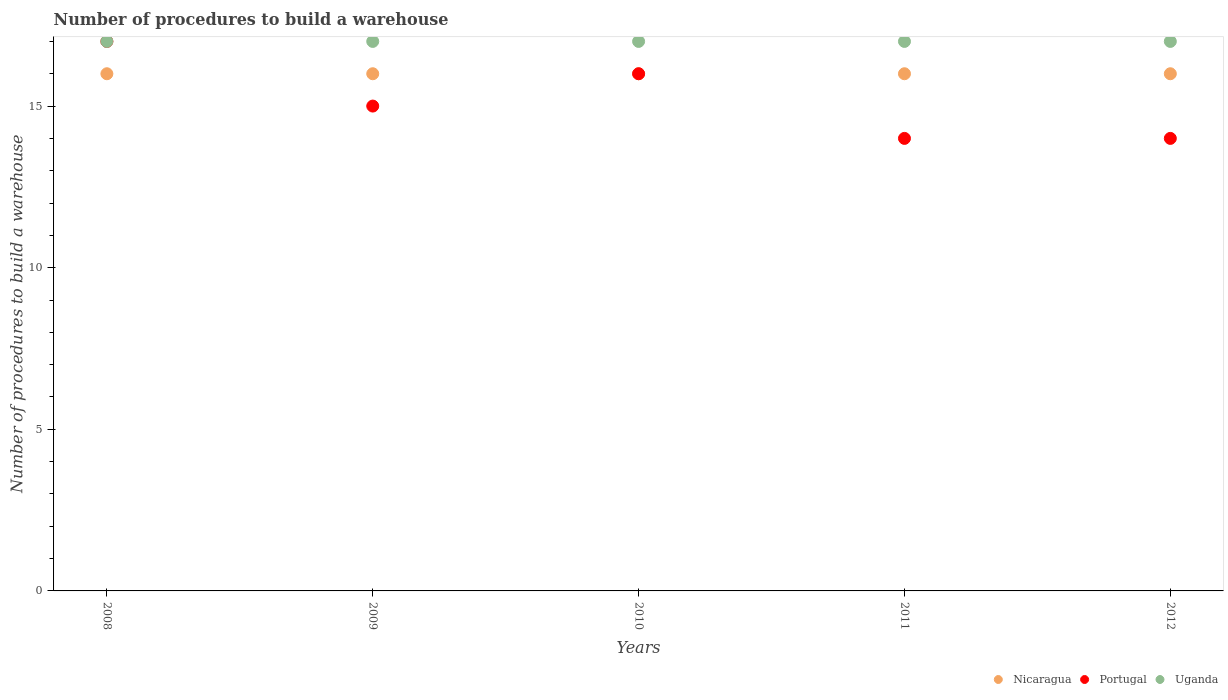How many different coloured dotlines are there?
Your answer should be compact. 3. What is the number of procedures to build a warehouse in in Portugal in 2011?
Offer a very short reply. 14. Across all years, what is the maximum number of procedures to build a warehouse in in Nicaragua?
Keep it short and to the point. 16. Across all years, what is the minimum number of procedures to build a warehouse in in Uganda?
Give a very brief answer. 17. In which year was the number of procedures to build a warehouse in in Uganda maximum?
Offer a very short reply. 2008. In which year was the number of procedures to build a warehouse in in Nicaragua minimum?
Your answer should be compact. 2008. What is the total number of procedures to build a warehouse in in Nicaragua in the graph?
Offer a very short reply. 80. What is the difference between the number of procedures to build a warehouse in in Uganda in 2008 and that in 2009?
Your answer should be very brief. 0. What is the difference between the number of procedures to build a warehouse in in Uganda in 2011 and the number of procedures to build a warehouse in in Nicaragua in 2010?
Give a very brief answer. 1. What is the average number of procedures to build a warehouse in in Nicaragua per year?
Provide a short and direct response. 16. In the year 2011, what is the difference between the number of procedures to build a warehouse in in Uganda and number of procedures to build a warehouse in in Nicaragua?
Your answer should be very brief. 1. What is the ratio of the number of procedures to build a warehouse in in Uganda in 2011 to that in 2012?
Offer a very short reply. 1. Is the difference between the number of procedures to build a warehouse in in Uganda in 2009 and 2012 greater than the difference between the number of procedures to build a warehouse in in Nicaragua in 2009 and 2012?
Give a very brief answer. No. What is the difference between the highest and the second highest number of procedures to build a warehouse in in Nicaragua?
Your response must be concise. 0. What is the difference between the highest and the lowest number of procedures to build a warehouse in in Uganda?
Your response must be concise. 0. Is the sum of the number of procedures to build a warehouse in in Portugal in 2009 and 2011 greater than the maximum number of procedures to build a warehouse in in Uganda across all years?
Your answer should be compact. Yes. How many dotlines are there?
Give a very brief answer. 3. What is the difference between two consecutive major ticks on the Y-axis?
Ensure brevity in your answer.  5. Are the values on the major ticks of Y-axis written in scientific E-notation?
Provide a succinct answer. No. Does the graph contain any zero values?
Provide a succinct answer. No. Does the graph contain grids?
Offer a terse response. No. How many legend labels are there?
Your answer should be compact. 3. What is the title of the graph?
Offer a very short reply. Number of procedures to build a warehouse. Does "Djibouti" appear as one of the legend labels in the graph?
Ensure brevity in your answer.  No. What is the label or title of the Y-axis?
Provide a succinct answer. Number of procedures to build a warehouse. What is the Number of procedures to build a warehouse in Nicaragua in 2008?
Provide a short and direct response. 16. What is the Number of procedures to build a warehouse in Portugal in 2008?
Ensure brevity in your answer.  17. What is the Number of procedures to build a warehouse in Uganda in 2008?
Provide a short and direct response. 17. What is the Number of procedures to build a warehouse in Nicaragua in 2009?
Provide a short and direct response. 16. What is the Number of procedures to build a warehouse of Uganda in 2009?
Give a very brief answer. 17. What is the Number of procedures to build a warehouse in Uganda in 2010?
Offer a terse response. 17. What is the Number of procedures to build a warehouse of Nicaragua in 2011?
Provide a short and direct response. 16. What is the Number of procedures to build a warehouse of Portugal in 2011?
Your response must be concise. 14. What is the Number of procedures to build a warehouse of Portugal in 2012?
Give a very brief answer. 14. Across all years, what is the maximum Number of procedures to build a warehouse of Nicaragua?
Give a very brief answer. 16. Across all years, what is the minimum Number of procedures to build a warehouse of Nicaragua?
Provide a succinct answer. 16. What is the total Number of procedures to build a warehouse of Uganda in the graph?
Keep it short and to the point. 85. What is the difference between the Number of procedures to build a warehouse in Portugal in 2008 and that in 2009?
Provide a short and direct response. 2. What is the difference between the Number of procedures to build a warehouse of Portugal in 2008 and that in 2010?
Give a very brief answer. 1. What is the difference between the Number of procedures to build a warehouse of Portugal in 2008 and that in 2011?
Offer a terse response. 3. What is the difference between the Number of procedures to build a warehouse in Portugal in 2008 and that in 2012?
Ensure brevity in your answer.  3. What is the difference between the Number of procedures to build a warehouse of Nicaragua in 2009 and that in 2011?
Provide a short and direct response. 0. What is the difference between the Number of procedures to build a warehouse in Uganda in 2009 and that in 2011?
Your answer should be very brief. 0. What is the difference between the Number of procedures to build a warehouse of Uganda in 2009 and that in 2012?
Provide a succinct answer. 0. What is the difference between the Number of procedures to build a warehouse in Nicaragua in 2010 and that in 2011?
Give a very brief answer. 0. What is the difference between the Number of procedures to build a warehouse of Uganda in 2010 and that in 2012?
Make the answer very short. 0. What is the difference between the Number of procedures to build a warehouse in Nicaragua in 2011 and that in 2012?
Provide a short and direct response. 0. What is the difference between the Number of procedures to build a warehouse of Portugal in 2008 and the Number of procedures to build a warehouse of Uganda in 2009?
Give a very brief answer. 0. What is the difference between the Number of procedures to build a warehouse of Portugal in 2008 and the Number of procedures to build a warehouse of Uganda in 2010?
Offer a very short reply. 0. What is the difference between the Number of procedures to build a warehouse in Nicaragua in 2008 and the Number of procedures to build a warehouse in Portugal in 2012?
Keep it short and to the point. 2. What is the difference between the Number of procedures to build a warehouse of Nicaragua in 2008 and the Number of procedures to build a warehouse of Uganda in 2012?
Ensure brevity in your answer.  -1. What is the difference between the Number of procedures to build a warehouse of Nicaragua in 2009 and the Number of procedures to build a warehouse of Uganda in 2010?
Your answer should be very brief. -1. What is the difference between the Number of procedures to build a warehouse in Nicaragua in 2009 and the Number of procedures to build a warehouse in Portugal in 2011?
Give a very brief answer. 2. What is the difference between the Number of procedures to build a warehouse of Nicaragua in 2009 and the Number of procedures to build a warehouse of Uganda in 2011?
Ensure brevity in your answer.  -1. What is the difference between the Number of procedures to build a warehouse in Portugal in 2009 and the Number of procedures to build a warehouse in Uganda in 2011?
Offer a very short reply. -2. What is the difference between the Number of procedures to build a warehouse of Nicaragua in 2009 and the Number of procedures to build a warehouse of Uganda in 2012?
Keep it short and to the point. -1. What is the difference between the Number of procedures to build a warehouse in Portugal in 2009 and the Number of procedures to build a warehouse in Uganda in 2012?
Provide a short and direct response. -2. What is the difference between the Number of procedures to build a warehouse of Nicaragua in 2010 and the Number of procedures to build a warehouse of Portugal in 2011?
Make the answer very short. 2. What is the difference between the Number of procedures to build a warehouse of Nicaragua in 2010 and the Number of procedures to build a warehouse of Portugal in 2012?
Offer a very short reply. 2. What is the difference between the Number of procedures to build a warehouse of Nicaragua in 2010 and the Number of procedures to build a warehouse of Uganda in 2012?
Your answer should be compact. -1. What is the difference between the Number of procedures to build a warehouse in Portugal in 2010 and the Number of procedures to build a warehouse in Uganda in 2012?
Provide a short and direct response. -1. What is the difference between the Number of procedures to build a warehouse in Nicaragua in 2011 and the Number of procedures to build a warehouse in Portugal in 2012?
Offer a very short reply. 2. What is the average Number of procedures to build a warehouse in Nicaragua per year?
Ensure brevity in your answer.  16. In the year 2008, what is the difference between the Number of procedures to build a warehouse of Nicaragua and Number of procedures to build a warehouse of Portugal?
Provide a short and direct response. -1. In the year 2008, what is the difference between the Number of procedures to build a warehouse of Nicaragua and Number of procedures to build a warehouse of Uganda?
Provide a succinct answer. -1. In the year 2009, what is the difference between the Number of procedures to build a warehouse of Nicaragua and Number of procedures to build a warehouse of Portugal?
Offer a very short reply. 1. In the year 2011, what is the difference between the Number of procedures to build a warehouse in Nicaragua and Number of procedures to build a warehouse in Portugal?
Ensure brevity in your answer.  2. In the year 2011, what is the difference between the Number of procedures to build a warehouse of Nicaragua and Number of procedures to build a warehouse of Uganda?
Make the answer very short. -1. In the year 2012, what is the difference between the Number of procedures to build a warehouse of Nicaragua and Number of procedures to build a warehouse of Portugal?
Your answer should be very brief. 2. In the year 2012, what is the difference between the Number of procedures to build a warehouse in Portugal and Number of procedures to build a warehouse in Uganda?
Offer a terse response. -3. What is the ratio of the Number of procedures to build a warehouse in Portugal in 2008 to that in 2009?
Give a very brief answer. 1.13. What is the ratio of the Number of procedures to build a warehouse in Uganda in 2008 to that in 2009?
Provide a short and direct response. 1. What is the ratio of the Number of procedures to build a warehouse in Nicaragua in 2008 to that in 2010?
Give a very brief answer. 1. What is the ratio of the Number of procedures to build a warehouse in Portugal in 2008 to that in 2011?
Make the answer very short. 1.21. What is the ratio of the Number of procedures to build a warehouse of Uganda in 2008 to that in 2011?
Your answer should be very brief. 1. What is the ratio of the Number of procedures to build a warehouse of Nicaragua in 2008 to that in 2012?
Your answer should be very brief. 1. What is the ratio of the Number of procedures to build a warehouse of Portugal in 2008 to that in 2012?
Provide a succinct answer. 1.21. What is the ratio of the Number of procedures to build a warehouse in Uganda in 2008 to that in 2012?
Your response must be concise. 1. What is the ratio of the Number of procedures to build a warehouse of Nicaragua in 2009 to that in 2010?
Keep it short and to the point. 1. What is the ratio of the Number of procedures to build a warehouse of Nicaragua in 2009 to that in 2011?
Keep it short and to the point. 1. What is the ratio of the Number of procedures to build a warehouse in Portugal in 2009 to that in 2011?
Ensure brevity in your answer.  1.07. What is the ratio of the Number of procedures to build a warehouse in Uganda in 2009 to that in 2011?
Ensure brevity in your answer.  1. What is the ratio of the Number of procedures to build a warehouse of Nicaragua in 2009 to that in 2012?
Offer a very short reply. 1. What is the ratio of the Number of procedures to build a warehouse in Portugal in 2009 to that in 2012?
Your response must be concise. 1.07. What is the ratio of the Number of procedures to build a warehouse of Portugal in 2010 to that in 2011?
Provide a succinct answer. 1.14. What is the ratio of the Number of procedures to build a warehouse of Uganda in 2010 to that in 2011?
Give a very brief answer. 1. What is the ratio of the Number of procedures to build a warehouse of Nicaragua in 2010 to that in 2012?
Provide a short and direct response. 1. What is the ratio of the Number of procedures to build a warehouse in Uganda in 2010 to that in 2012?
Make the answer very short. 1. What is the ratio of the Number of procedures to build a warehouse in Portugal in 2011 to that in 2012?
Offer a terse response. 1. What is the difference between the highest and the lowest Number of procedures to build a warehouse of Uganda?
Give a very brief answer. 0. 